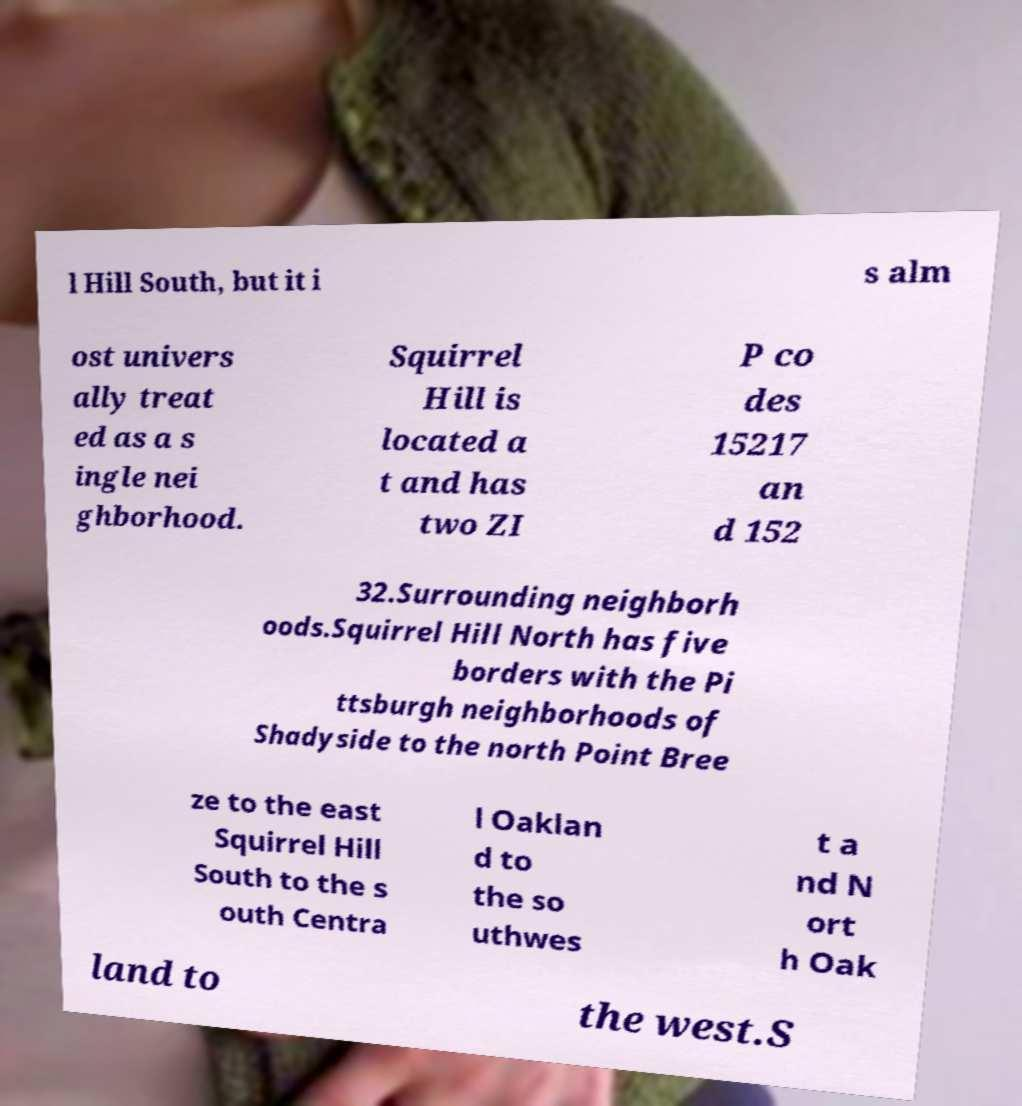Can you read and provide the text displayed in the image?This photo seems to have some interesting text. Can you extract and type it out for me? l Hill South, but it i s alm ost univers ally treat ed as a s ingle nei ghborhood. Squirrel Hill is located a t and has two ZI P co des 15217 an d 152 32.Surrounding neighborh oods.Squirrel Hill North has five borders with the Pi ttsburgh neighborhoods of Shadyside to the north Point Bree ze to the east Squirrel Hill South to the s outh Centra l Oaklan d to the so uthwes t a nd N ort h Oak land to the west.S 